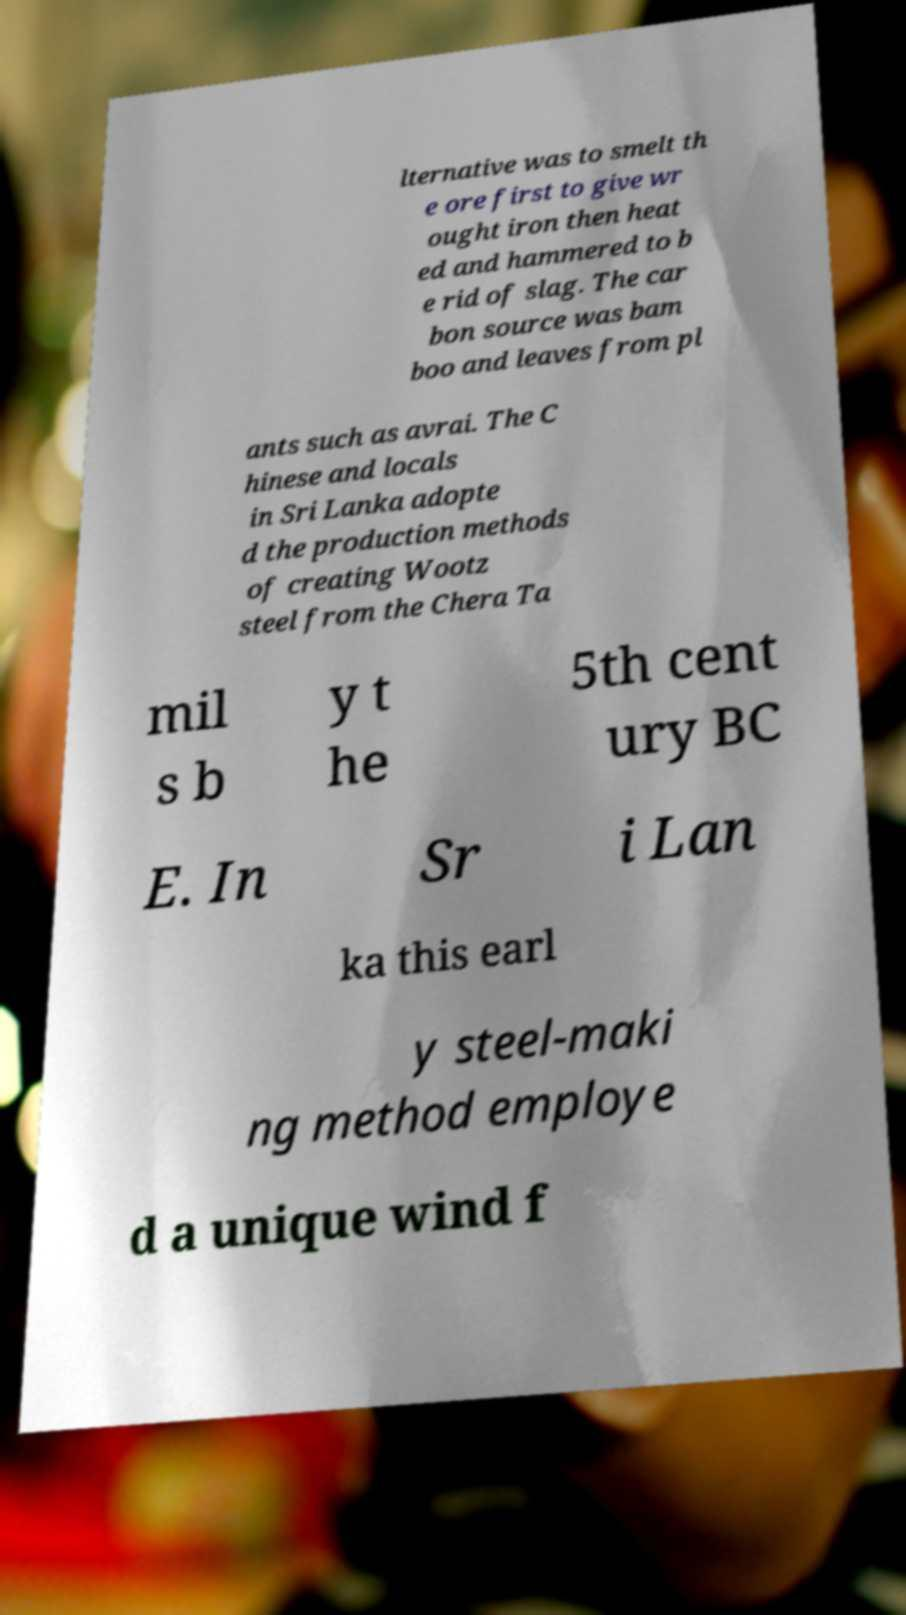Can you accurately transcribe the text from the provided image for me? lternative was to smelt th e ore first to give wr ought iron then heat ed and hammered to b e rid of slag. The car bon source was bam boo and leaves from pl ants such as avrai. The C hinese and locals in Sri Lanka adopte d the production methods of creating Wootz steel from the Chera Ta mil s b y t he 5th cent ury BC E. In Sr i Lan ka this earl y steel-maki ng method employe d a unique wind f 